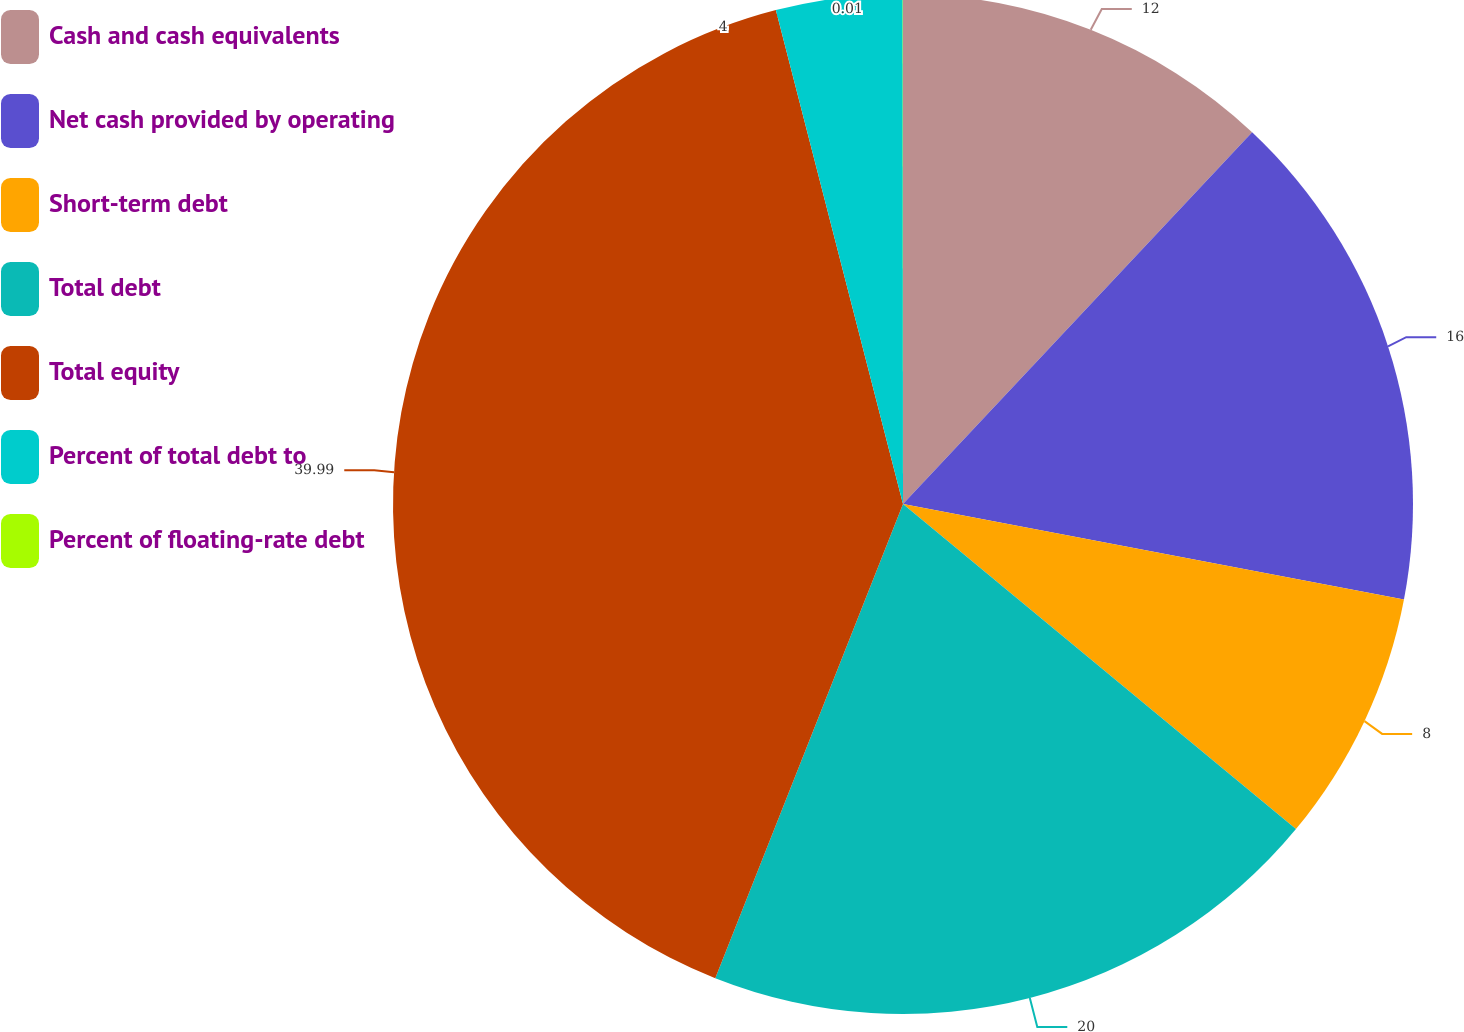Convert chart to OTSL. <chart><loc_0><loc_0><loc_500><loc_500><pie_chart><fcel>Cash and cash equivalents<fcel>Net cash provided by operating<fcel>Short-term debt<fcel>Total debt<fcel>Total equity<fcel>Percent of total debt to<fcel>Percent of floating-rate debt<nl><fcel>12.0%<fcel>16.0%<fcel>8.0%<fcel>20.0%<fcel>39.99%<fcel>4.0%<fcel>0.01%<nl></chart> 